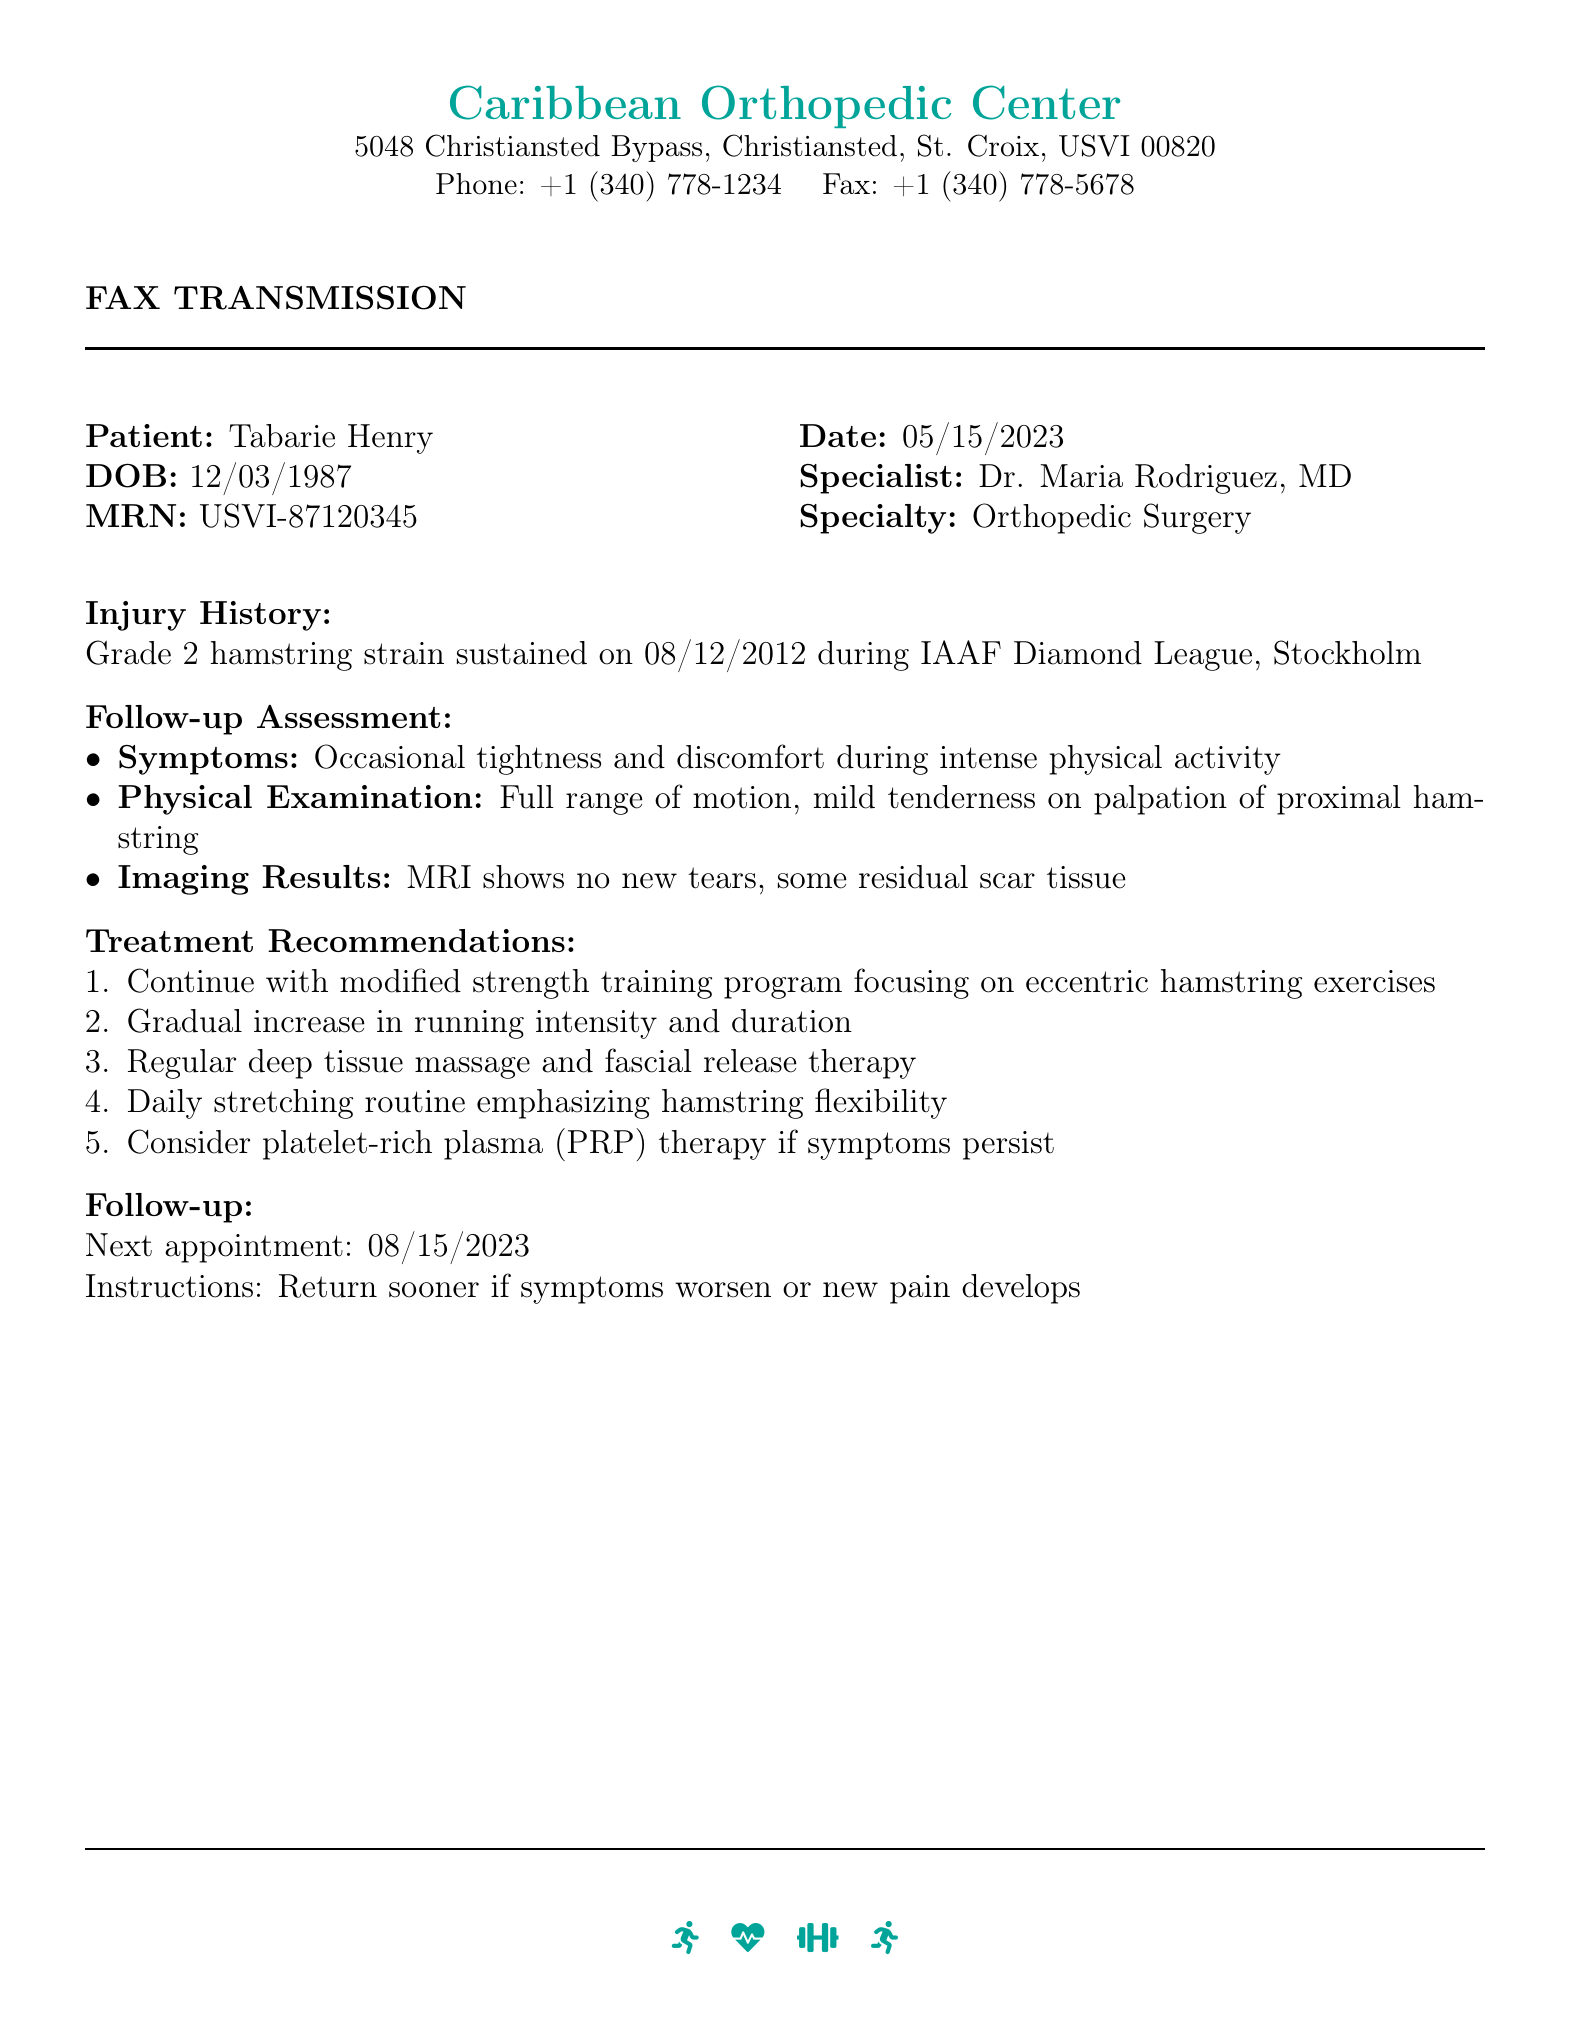What is the patient's name? The patient's name is prominently stated in the fax and is the first piece of information given.
Answer: Tabarie Henry What was the date of the follow-up assessment? The date of the follow-up assessment is given clearly in the document as part of the header.
Answer: 05/15/2023 Who is the orthopedic specialist? The orthopedic specialist is mentioned right after the date, providing clear identification of the medical professional.
Answer: Dr. Maria Rodriguez, MD What is the primary injury discussed in the report? The report specifies the type of injury in the injury history section.
Answer: Grade 2 hamstring strain What is the next appointment date? The next appointment date is mentioned in the follow-up section, indicating the schedule ahead.
Answer: 08/15/2023 What symptom persists during intense physical activity? The symptom is outlined under follow-up assessment and is the primary concern during activities.
Answer: Tightness and discomfort What type of therapy is suggested if symptoms persist? This recommendation is clearly stated under treatment recommendations.
Answer: Platelet-rich plasma (PRP) therapy What specific type of physical therapy is recommended? The document provides detailed suggestions under treatment recommendations.
Answer: Deep tissue massage What imaging result is mentioned in the report? The imaging results are described under follow-up assessment, indicating findings related to the condition.
Answer: MRI shows no new tears 